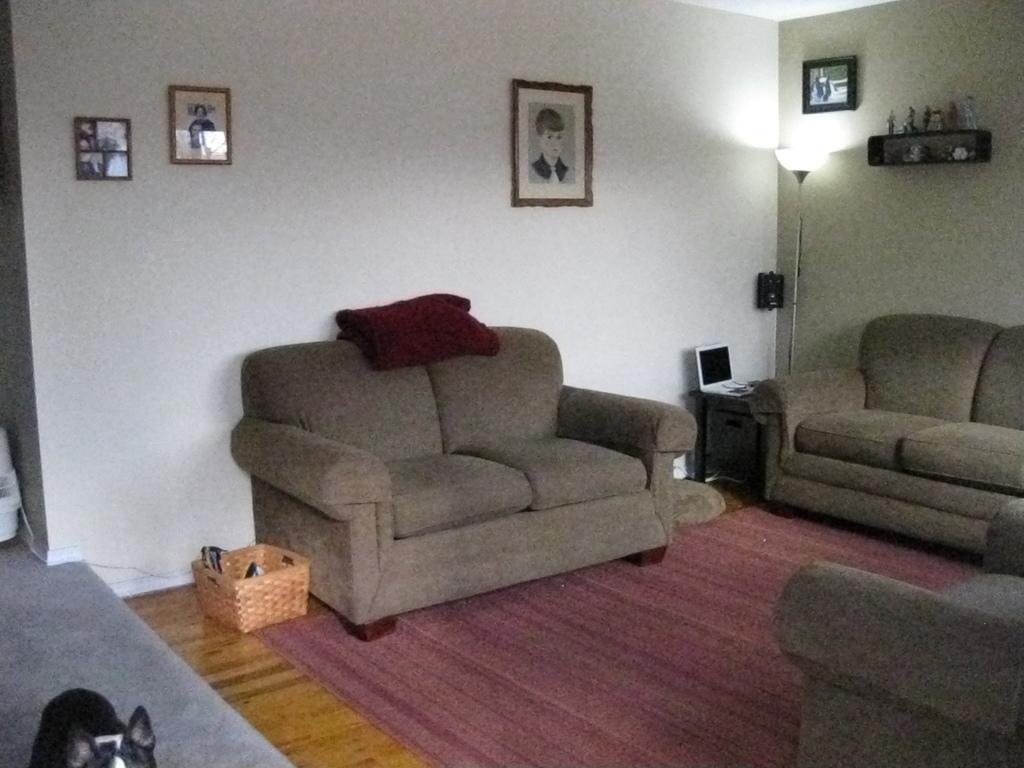In one or two sentences, can you explain what this image depicts? In this image i can see few couches, a towel , a basket and a animal. In the background i can see the wall, few photo frames attached to the wall, a lamp,a shelf and few objects in it ,a laptop and the floor mat. 